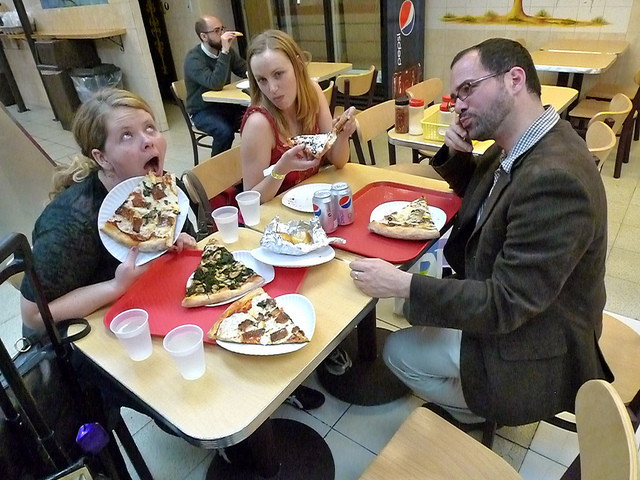Can you describe the atmosphere of the place they are in? The atmosphere seems informal and relaxed, characterized by a simple interior decor typical of a quick-service restaurant. The presence of disposable cups and paper plates suggests a focus on convenience. 